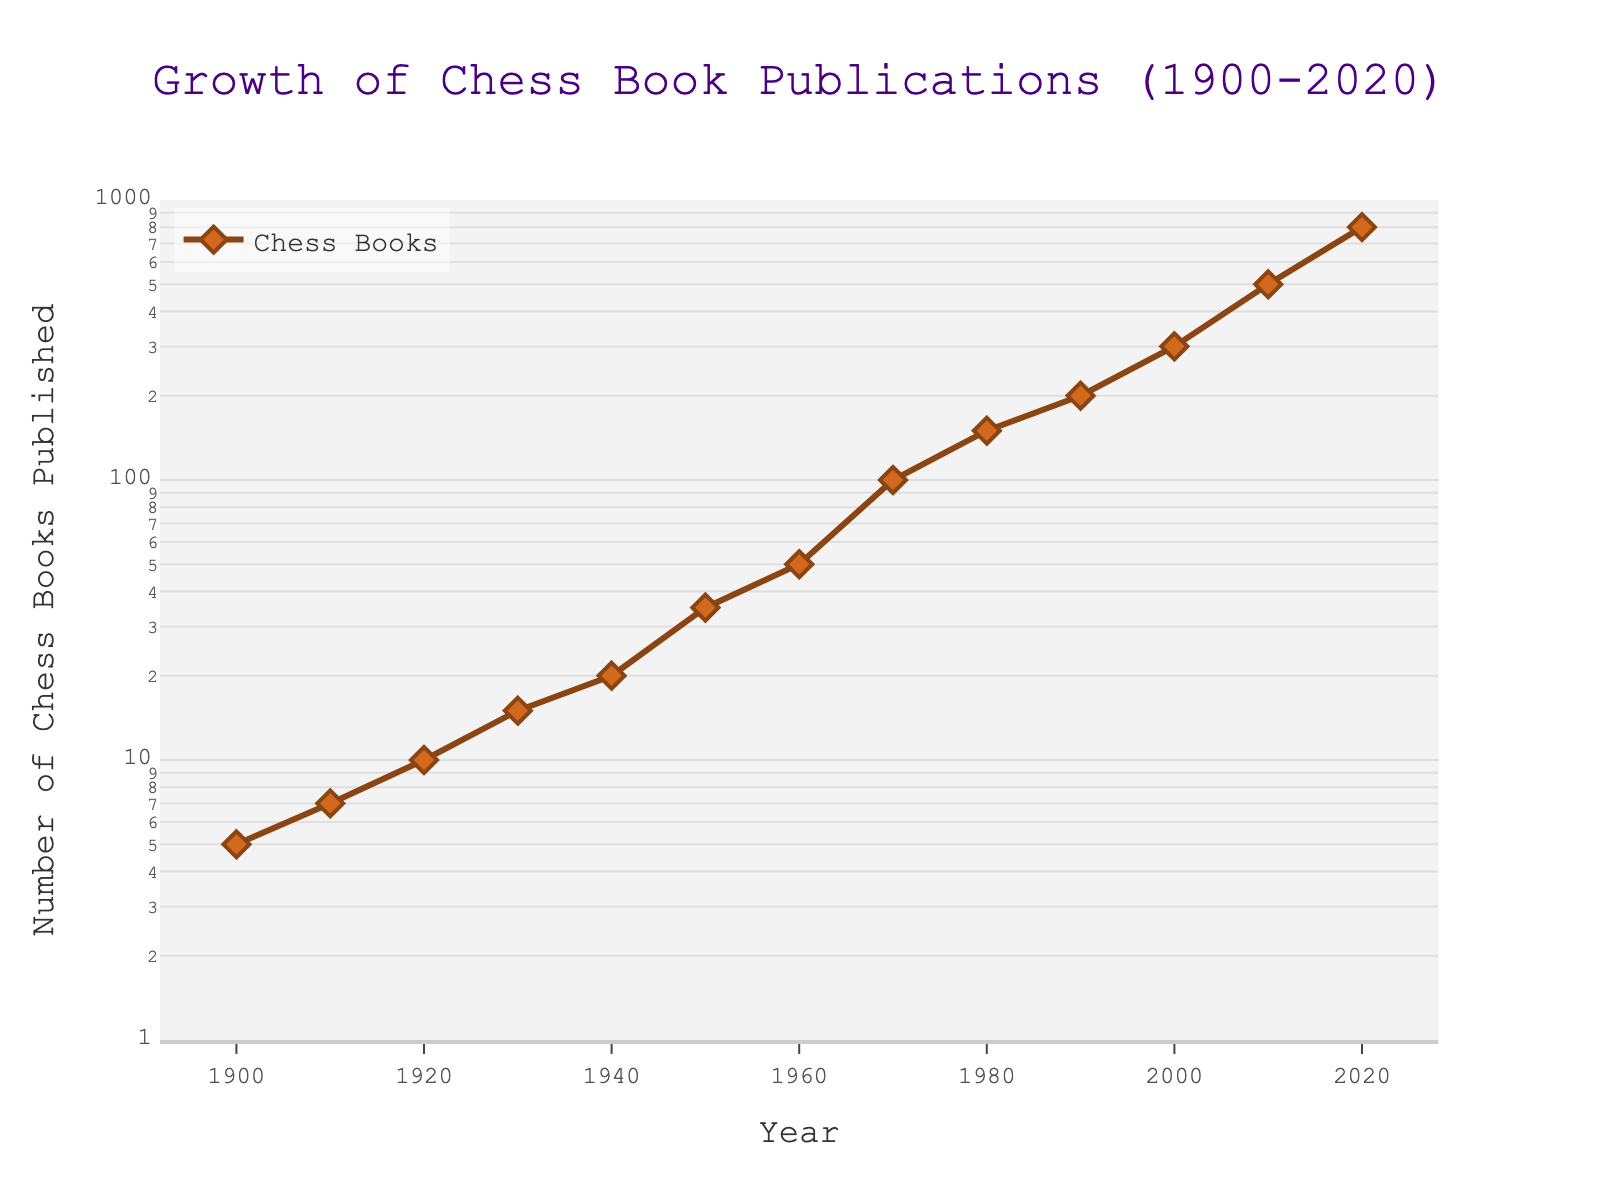What's the title of the plot? The title of the plot is displayed at the top center of the figure. It reads "Growth of Chess Book Publications (1900-2020)".
Answer: Growth of Chess Book Publications (1900-2020) What is the number of chess books published in 1950? By looking along the x-axis to the year 1950 and then moving upwards to the data point, the y-value corresponding to 1950 is observed to be 35.
Answer: 35 What does the annotation near 1972 indicate? The annotation near the year 1972 points out an important historical event related to chess. It reads "Fischer vs Spassky" and refers to the famous 1972 World Chess Championship match between Bobby Fischer and Boris Spassky.
Answer: Fischer vs Spassky How many years are covered in the plot? The x-axis of the plot starts from the year 1900 and goes up to 2020. The total number of years covered is computed by subtracting 1900 from 2020 and then adding one (since both endpoints are included). Therefore, 2020 - 1900 + 1 = 121 years.
Answer: 121 How did the number of chess book publications change from 1900 to 1940? The number of books published in 1900 was 5, and by 1940 it increased to 20. To find the change, subtract the number in 1900 from the number in 1940: 20 - 5 = 15. The publications increased by 15.
Answer: Increased by 15 Which decade saw the highest growth rate in chess book publications? To determine the decade with the highest growth rate, examine the change in the number of publications between each decade. Significant growth can be seen between 1960 (50 books) and 1970 (100 books), showing a doubling in that decade.
Answer: 1960s By what factor did the number of chess books published increase from 1980 to 2020? In 1980, there were 150 books published, and in 2020, there were 800. To find the factor of increase, divide the later number by the earlier number: 800 / 150 ≈ 5.33. So, the number of publications increased by approximately a factor of 5.33.
Answer: 5.33 What are the significant events marked in the plot, and what years do they correspond to? The annotations highlight significant events related to chess. The two notable events are "Fischer's Birth" marked in 1950 and "Fischer vs Spassky" marked in 1972.
Answer: Fischer's Birth (1950), Fischer vs Spassky (1972) 